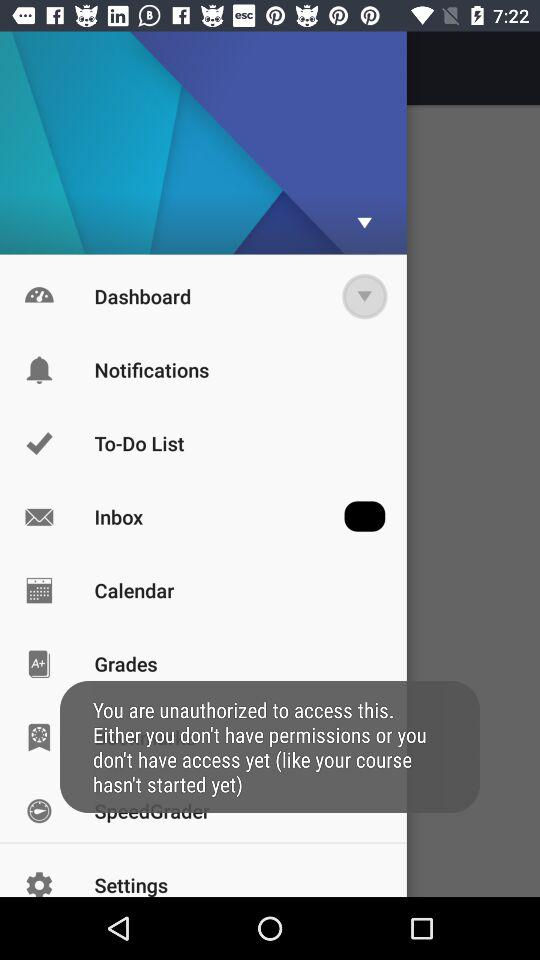What is the status of the inbox? The status of the inbox is on. 